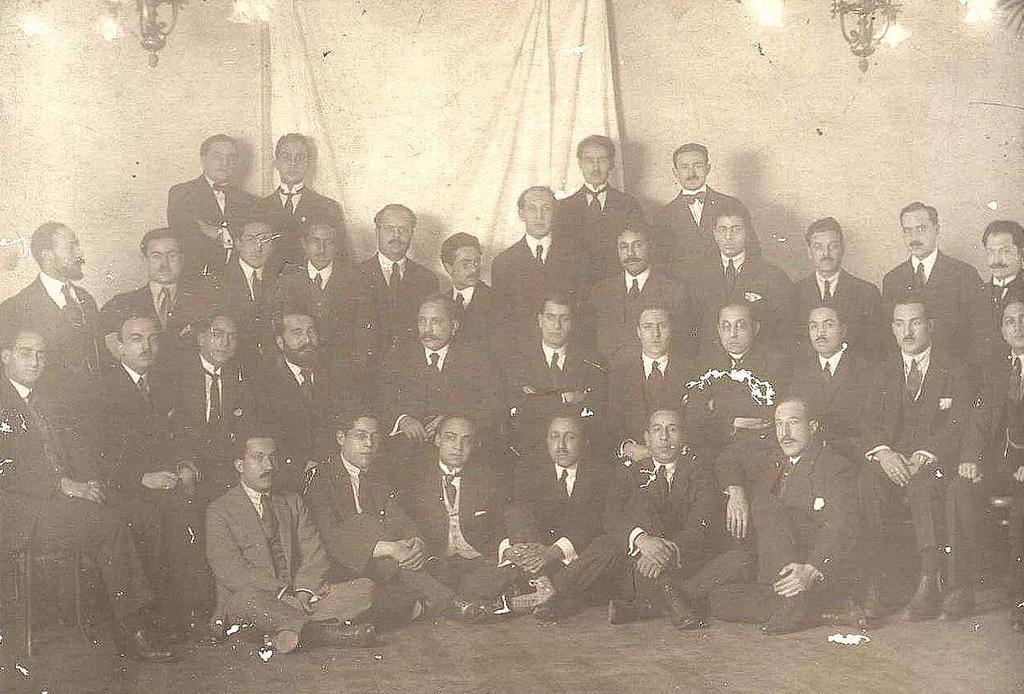How many people are in the group visible in the image? The number of people in the group cannot be determined from the provided facts. What is the background of the image? There is a wall visible in the image. What type of material is the cloth in the image made of? The material of the cloth cannot be determined from the provided facts. What is the source of illumination in the image? Lights are present at the top of the image. What type of stamp is being used by the person in the image? There is no stamp present in the image. What is the chance of winning a prize in the image? There is no indication of a prize or a game in the image. 